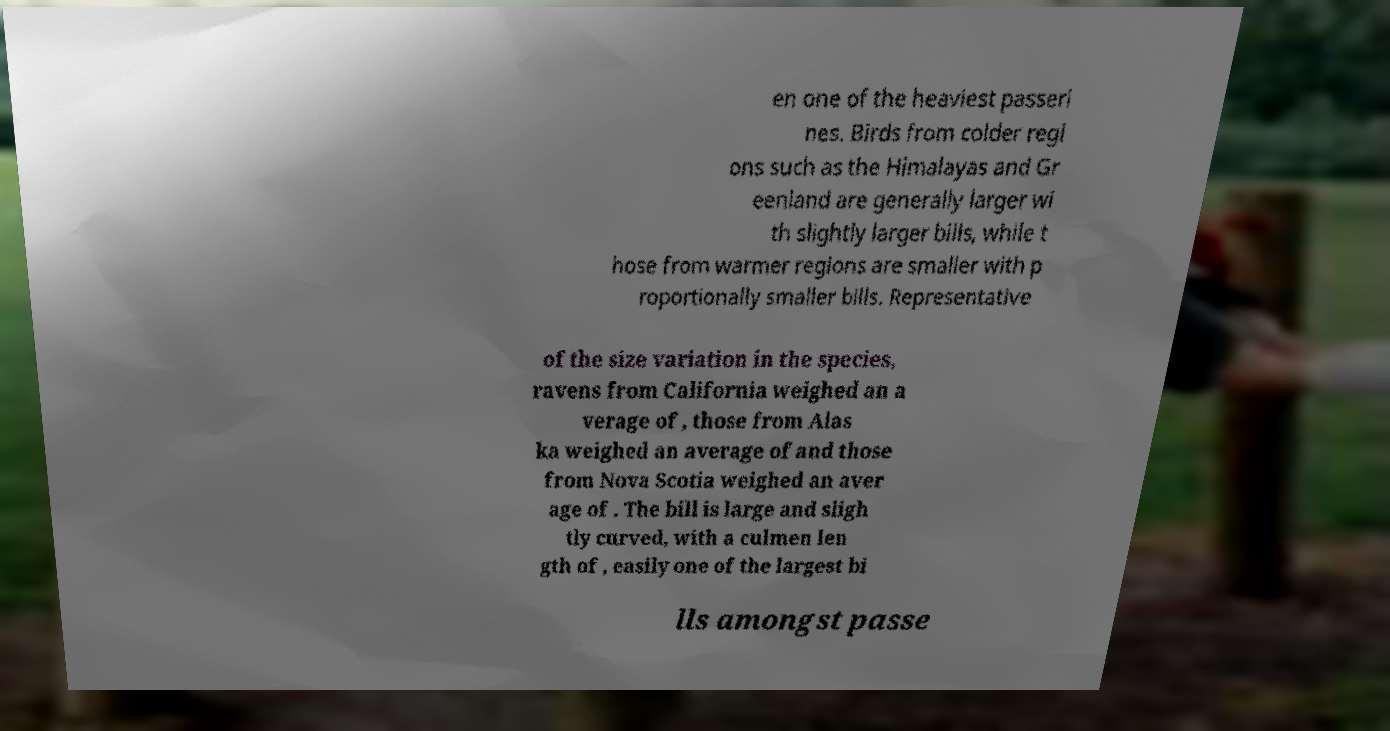Please identify and transcribe the text found in this image. en one of the heaviest passeri nes. Birds from colder regi ons such as the Himalayas and Gr eenland are generally larger wi th slightly larger bills, while t hose from warmer regions are smaller with p roportionally smaller bills. Representative of the size variation in the species, ravens from California weighed an a verage of , those from Alas ka weighed an average of and those from Nova Scotia weighed an aver age of . The bill is large and sligh tly curved, with a culmen len gth of , easily one of the largest bi lls amongst passe 